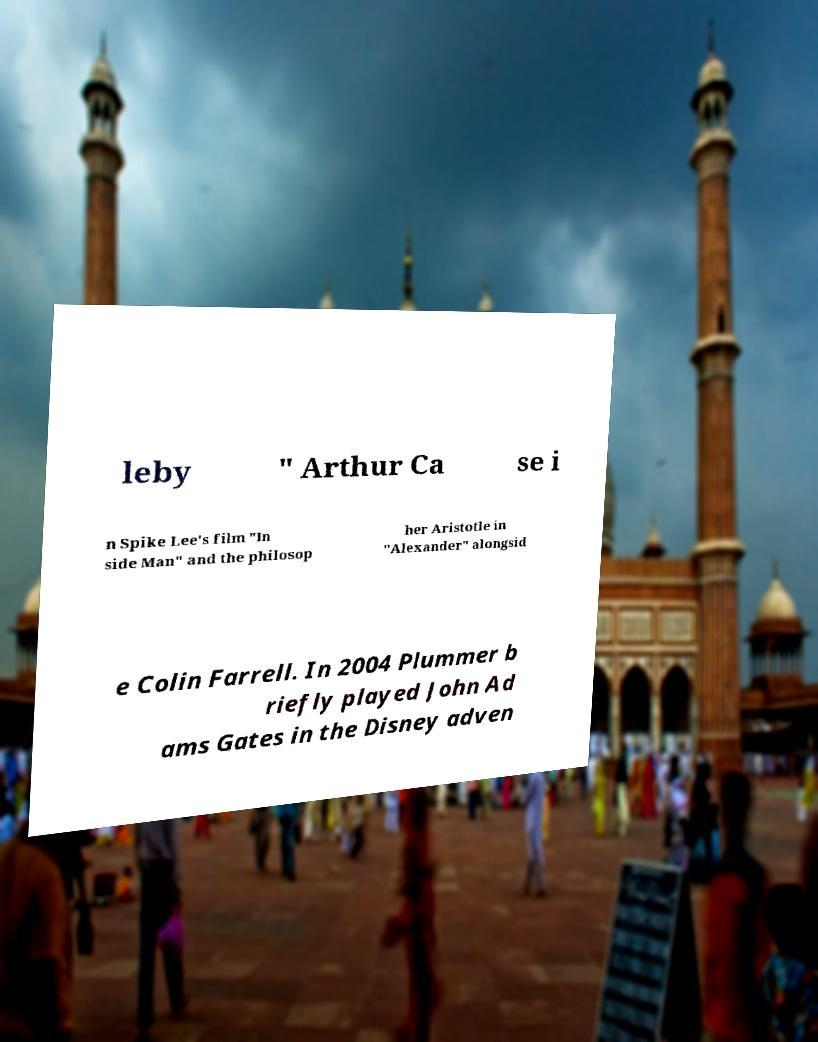Please identify and transcribe the text found in this image. leby " Arthur Ca se i n Spike Lee's film "In side Man" and the philosop her Aristotle in "Alexander" alongsid e Colin Farrell. In 2004 Plummer b riefly played John Ad ams Gates in the Disney adven 